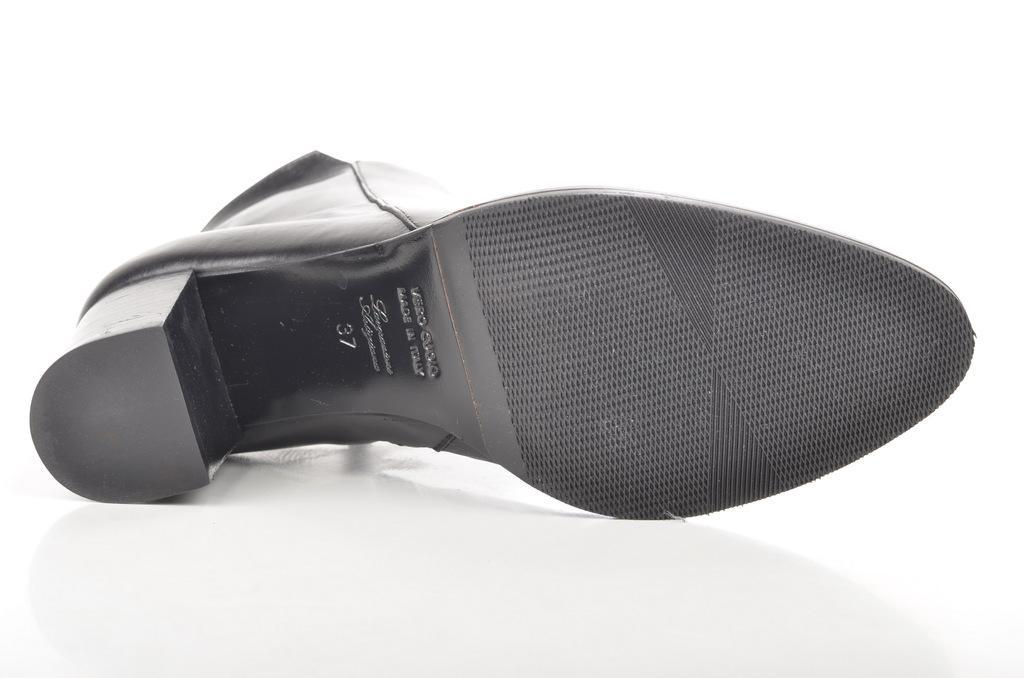Describe this image in one or two sentences. In this picture there is a bottom of a show which has something written on it is in black color. 